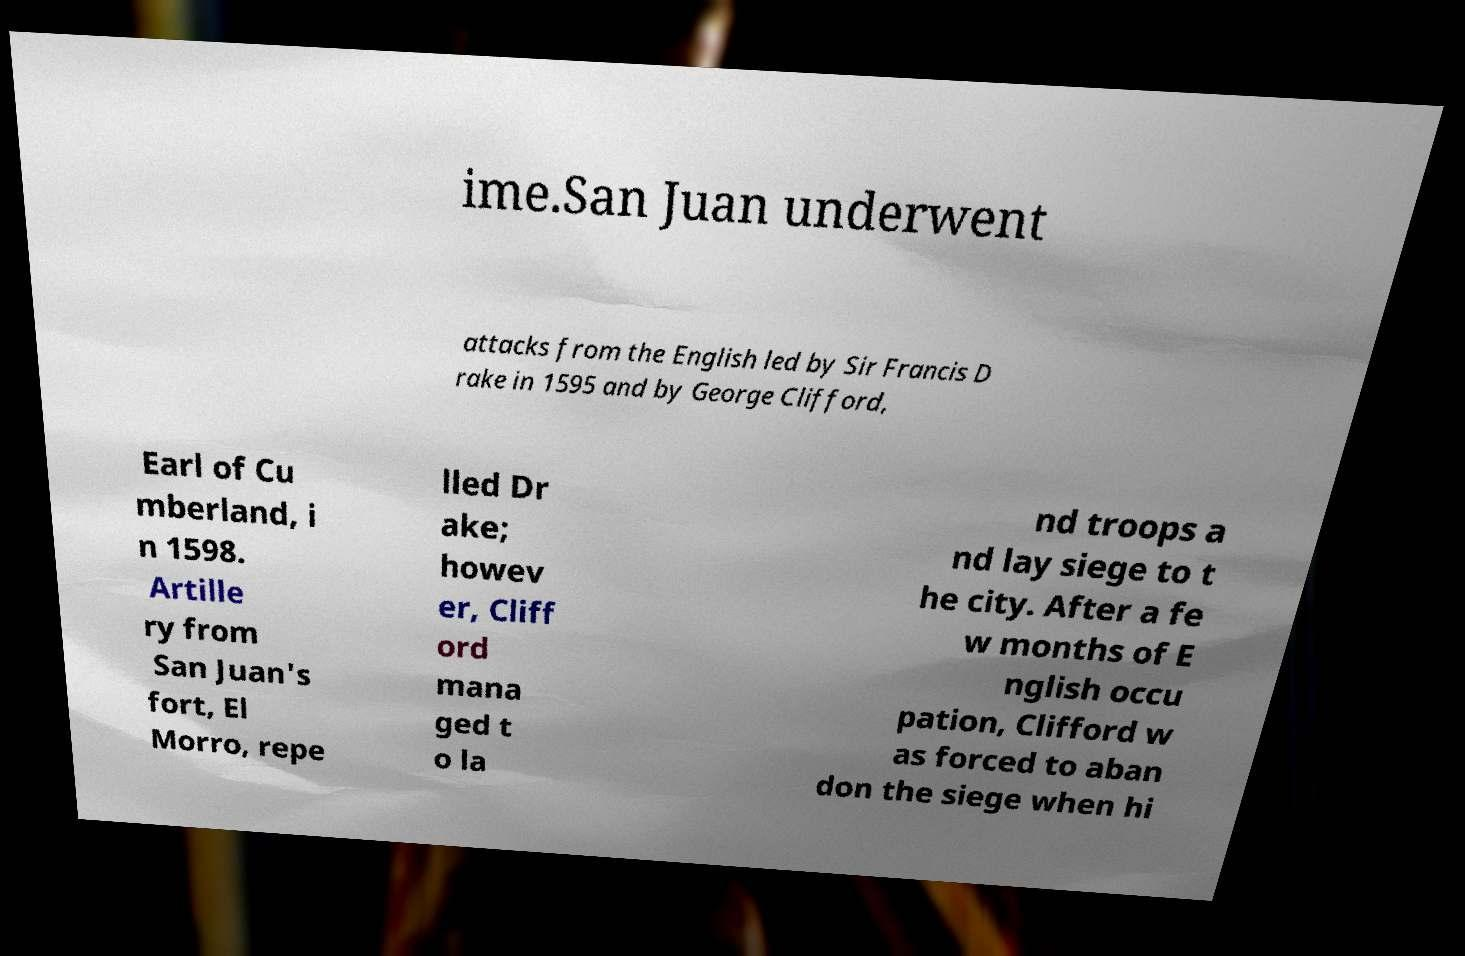For documentation purposes, I need the text within this image transcribed. Could you provide that? ime.San Juan underwent attacks from the English led by Sir Francis D rake in 1595 and by George Clifford, Earl of Cu mberland, i n 1598. Artille ry from San Juan's fort, El Morro, repe lled Dr ake; howev er, Cliff ord mana ged t o la nd troops a nd lay siege to t he city. After a fe w months of E nglish occu pation, Clifford w as forced to aban don the siege when hi 